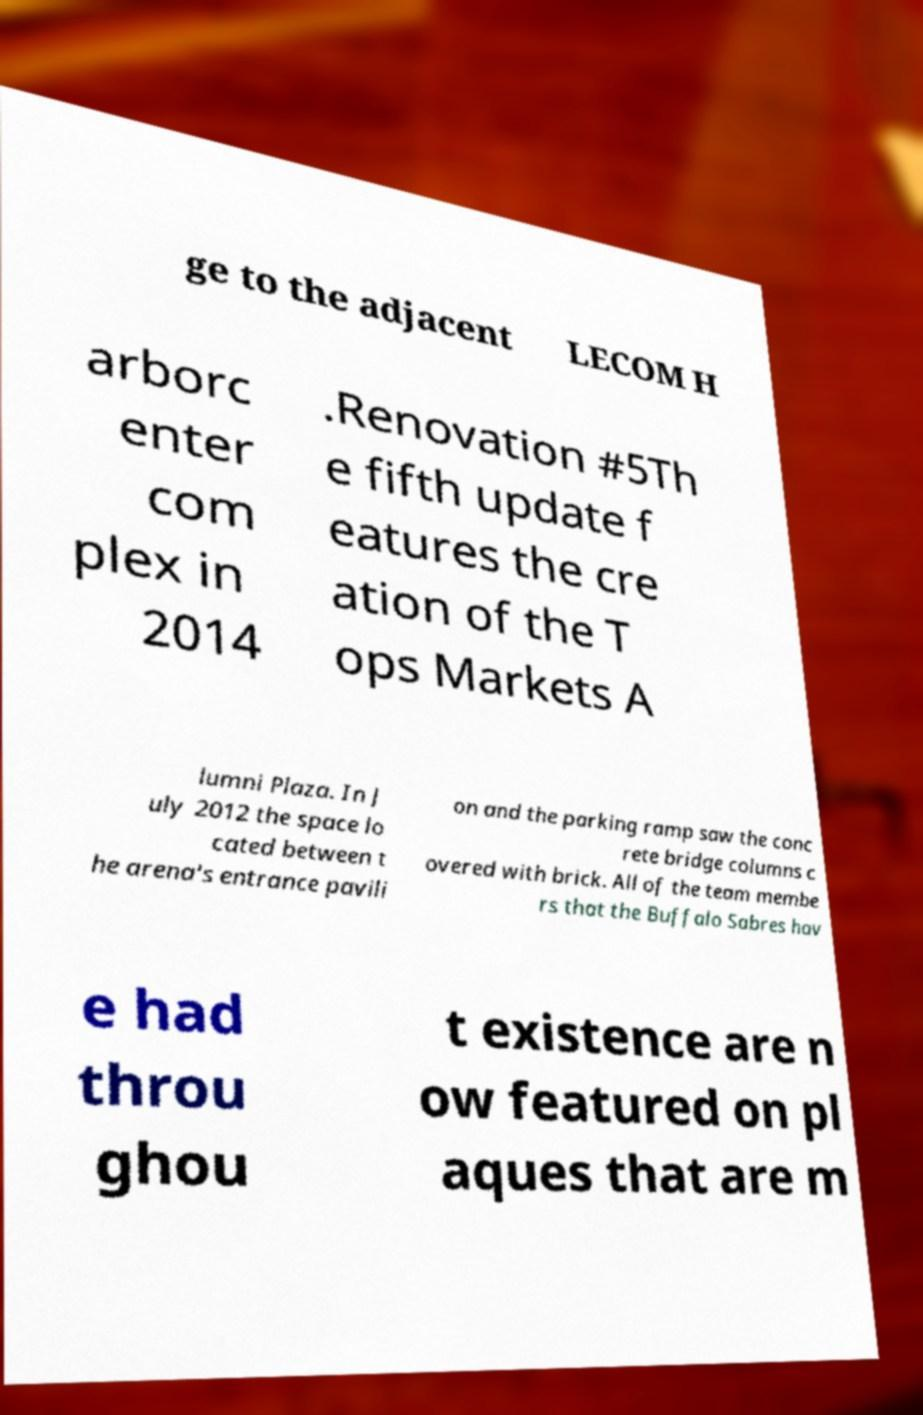Please read and relay the text visible in this image. What does it say? ge to the adjacent LECOM H arborc enter com plex in 2014 .Renovation #5Th e fifth update f eatures the cre ation of the T ops Markets A lumni Plaza. In J uly 2012 the space lo cated between t he arena's entrance pavili on and the parking ramp saw the conc rete bridge columns c overed with brick. All of the team membe rs that the Buffalo Sabres hav e had throu ghou t existence are n ow featured on pl aques that are m 